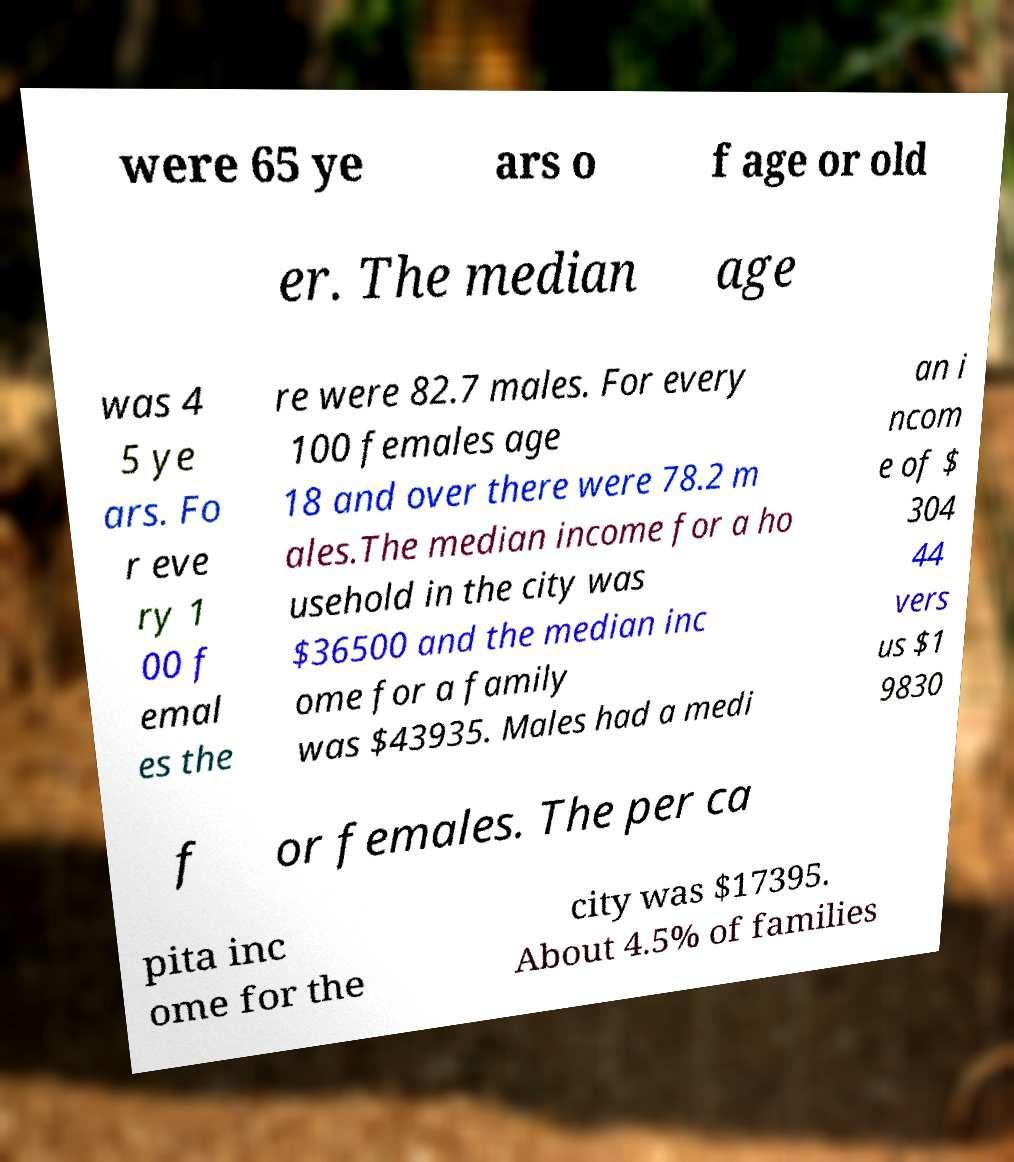Could you assist in decoding the text presented in this image and type it out clearly? were 65 ye ars o f age or old er. The median age was 4 5 ye ars. Fo r eve ry 1 00 f emal es the re were 82.7 males. For every 100 females age 18 and over there were 78.2 m ales.The median income for a ho usehold in the city was $36500 and the median inc ome for a family was $43935. Males had a medi an i ncom e of $ 304 44 vers us $1 9830 f or females. The per ca pita inc ome for the city was $17395. About 4.5% of families 